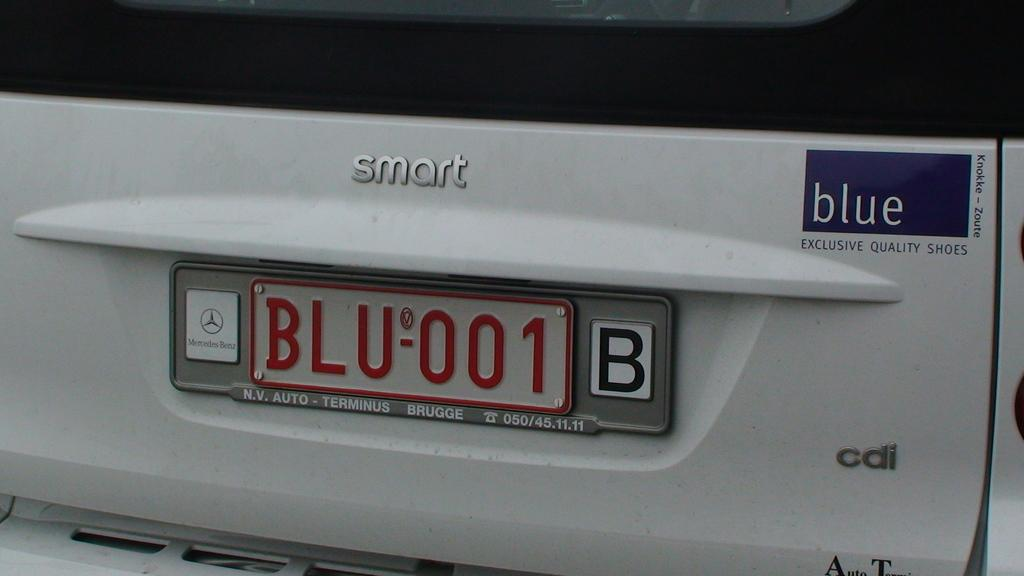What can be seen on the vehicle in the image? There is text on a vehicle in the image. Can you identify any specific detail on the vehicle? Yes, there is a number plate in the image. Are there any balls visible in the image? There are no balls present in the image. Is there a volcano in the background of the image? There is no volcano visible in the image. 